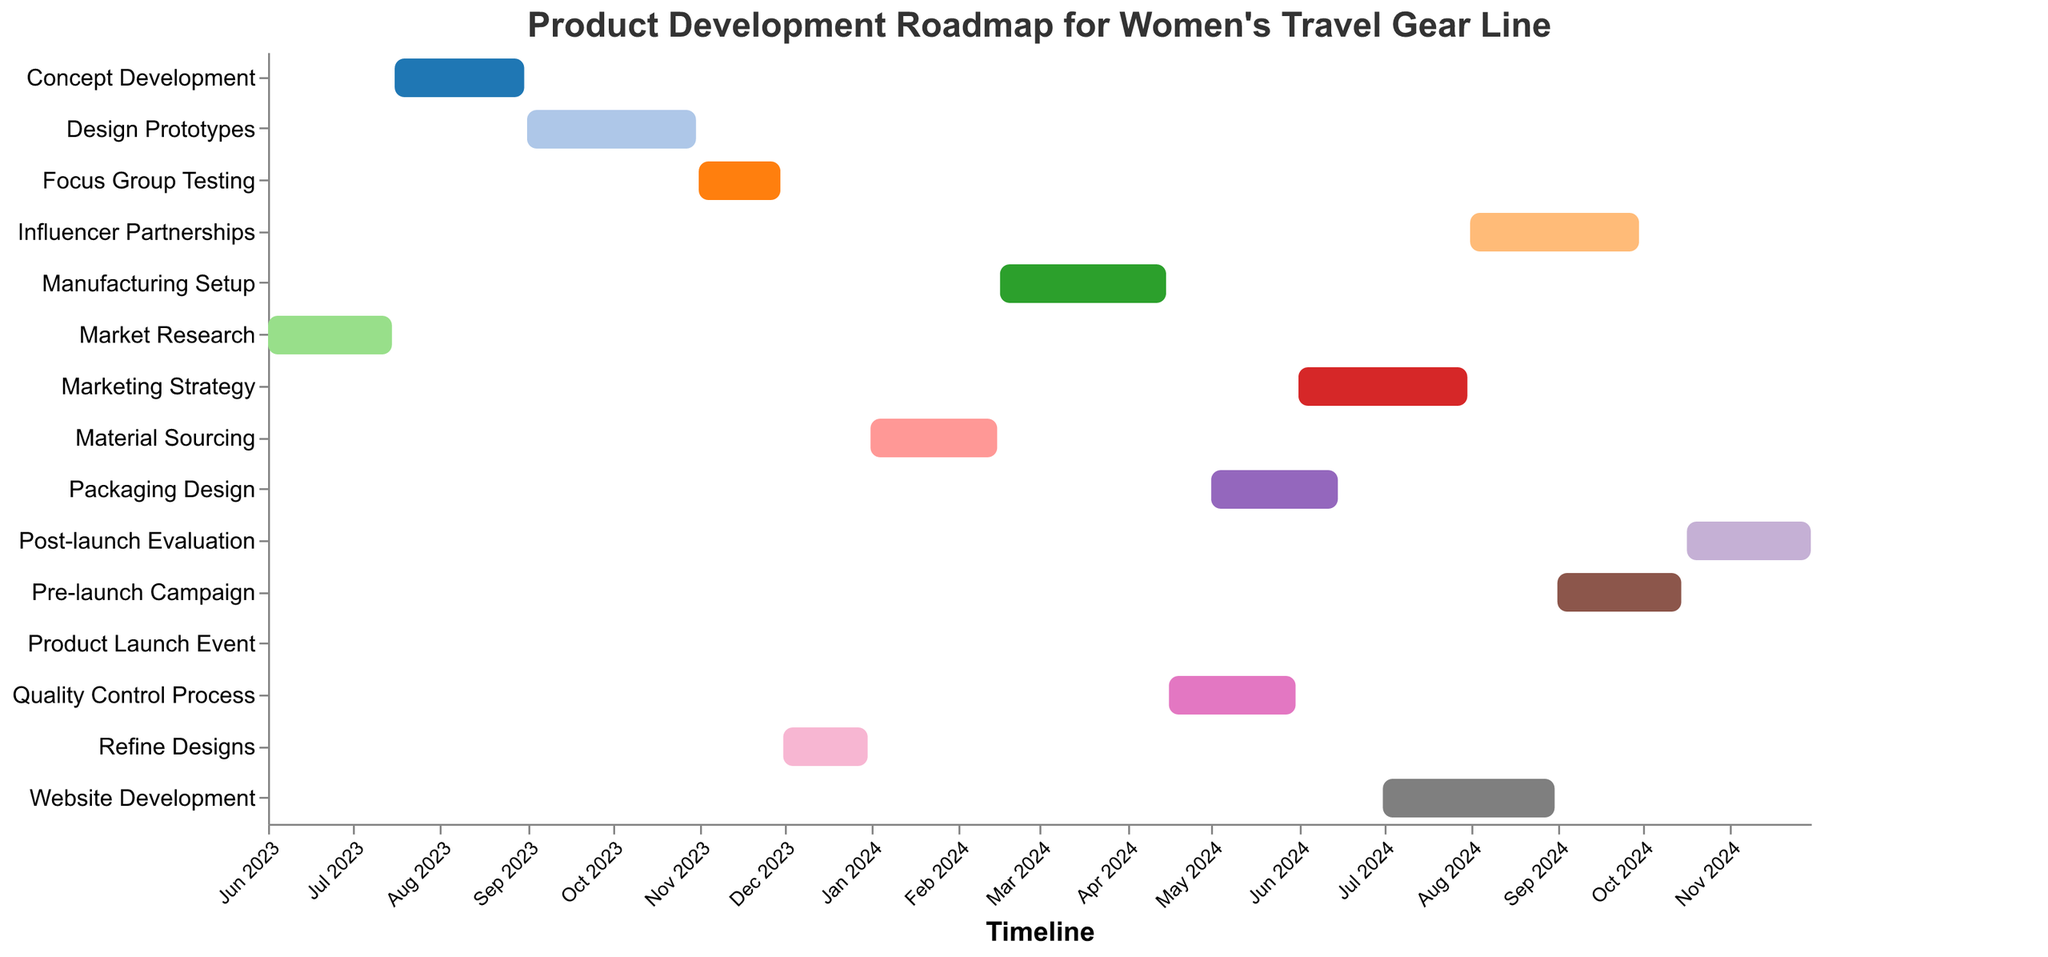What is the title of the Gantt Chart? The title of the Gantt Chart is prominently displayed at the top of the figure.
Answer: Product Development Roadmap for Women's Travel Gear Line Which task starts first and when does it start? The task with the earliest start date is the first task. According to the data, it's the "Market Research" task which starts on 2023-06-01.
Answer: Market Research starts on 2023-06-01 What is the duration of the Design Prototypes task? The duration of a task can be calculated by finding the difference between the end date and the start date. For the task "Design Prototypes", the start date is 2023-09-01 and the end date is 2023-10-31. So, the duration is 61 days (inclusive).
Answer: 61 days Which task ends after Packaging Design begins? To determine this, look at the end dates of all tasks and compare them with the start date of "Packaging Design" (2024-05-01). The tasks that end after this date include "Marketing Strategy", "Website Development", "Influencer Partnerships", "Pre-launch Campaign", "Product Launch Event", and "Post-launch Evaluation".
Answer: Marketing Strategy, Website Development, Influencer Partnerships, Pre-launch Campaign, Product Launch Event, Post-launch Evaluation What are the tasks that last for exactly one month? Here, we need to identify tasks whose durations are approximately 30 days. Comparing the start and end dates of each task, "Focus Group Testing" (2023-11-01 to 2023-11-30) and "Refine Designs" (2023-12-01 to 2023-12-31) each last for exactly one month.
Answer: Focus Group Testing, Refine Designs Which task is scheduled to start just after the Concept Development ends? "Concept Development" ends on 2023-08-31. The next task that starts the day after this is "Design Prototypes", which begins on 2023-09-01.
Answer: Design Prototypes How many tasks overlap with Market Research based on their start and end dates? "Market Research" runs from 2023-06-01 to 2023-07-15. To find overlapping tasks, we need to check which tasks have any part of their duration within this timeframe. After reviewing the data, no other tasks overlap with Market Research.
Answer: 0 tasks overlap What is the sequence of tasks leading up to the Product Launch Event? To identify this, list the tasks in sequence that come before the "Product Launch Event" scheduled for 2024-10-16. The sequence of tasks leading up to this is: "Market Research", "Concept Development", "Design Prototypes", "Focus Group Testing", "Refine Designs", "Material Sourcing", "Manufacturing Setup", "Quality Control Process", "Packaging Design", "Marketing Strategy", "Website Development", "Influencer Partnerships", "Pre-launch Campaign".
Answer: Market Research, Concept Development, Design Prototypes, Focus Group Testing, Refine Designs, Material Sourcing, Manufacturing Setup, Quality Control Process, Packaging Design, Marketing Strategy, Website Development, Influencer Partnerships, Pre-launch Campaign Which tasks will be active during January 2024? Tasks active during a specific period can be found by checking their start and end dates. In January 2024, "Refine Designs" (scheduled until 2023-12-31), "Material Sourcing" (starting 2024-01-01), and "Manufacturing Setup" (starting 2024-02-16) are relevant.
Answer: Refine Designs, Material Sourcing What is the order of tasks that follow after the Marketing Strategy task? "Marketing Strategy" ends on 2024-07-31. The subsequent tasks are "Website Development" (starting 2024-07-01 to 2024-08-31), "Influencer Partnerships" (starting 2024-08-01 to 2024-09-30), "Pre-launch Campaign" (starting 2024-09-01 to 2024-10-15), "Product Launch Event" (occurring 2024-10-16), "Post-launch Evaluation" (beginning the day after the product launch).
Answer: Website Development, Influencer Partnerships, Pre-launch Campaign, Product Launch Event, Post-launch Evaluation 